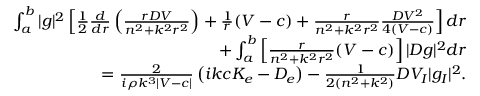<formula> <loc_0><loc_0><loc_500><loc_500>\begin{array} { r } { \int _ { a } ^ { b } | g | ^ { 2 } \left [ \frac { 1 } { 2 } \frac { d } { d r } \left ( \frac { r D V } { n ^ { 2 } + k ^ { 2 } r ^ { 2 } } \right ) + \frac { 1 } { r } ( V - c ) + \frac { r } { n ^ { 2 } + k ^ { 2 } r ^ { 2 } } \frac { D V ^ { 2 } } { 4 ( V - c ) } \right ] d r } \\ { + \int _ { a } ^ { b } \left [ \frac { r } { n ^ { 2 } + k ^ { 2 } r ^ { 2 } } ( V - c ) \right ] | D g | ^ { 2 } d r } \\ { = \frac { 2 } { i \rho k ^ { 3 } | V - c | } \left ( i k c K _ { e } - D _ { e } \right ) - \frac { 1 } { 2 ( n ^ { 2 } + k ^ { 2 } ) } D V _ { I } | g _ { I } | ^ { 2 } . } \end{array}</formula> 